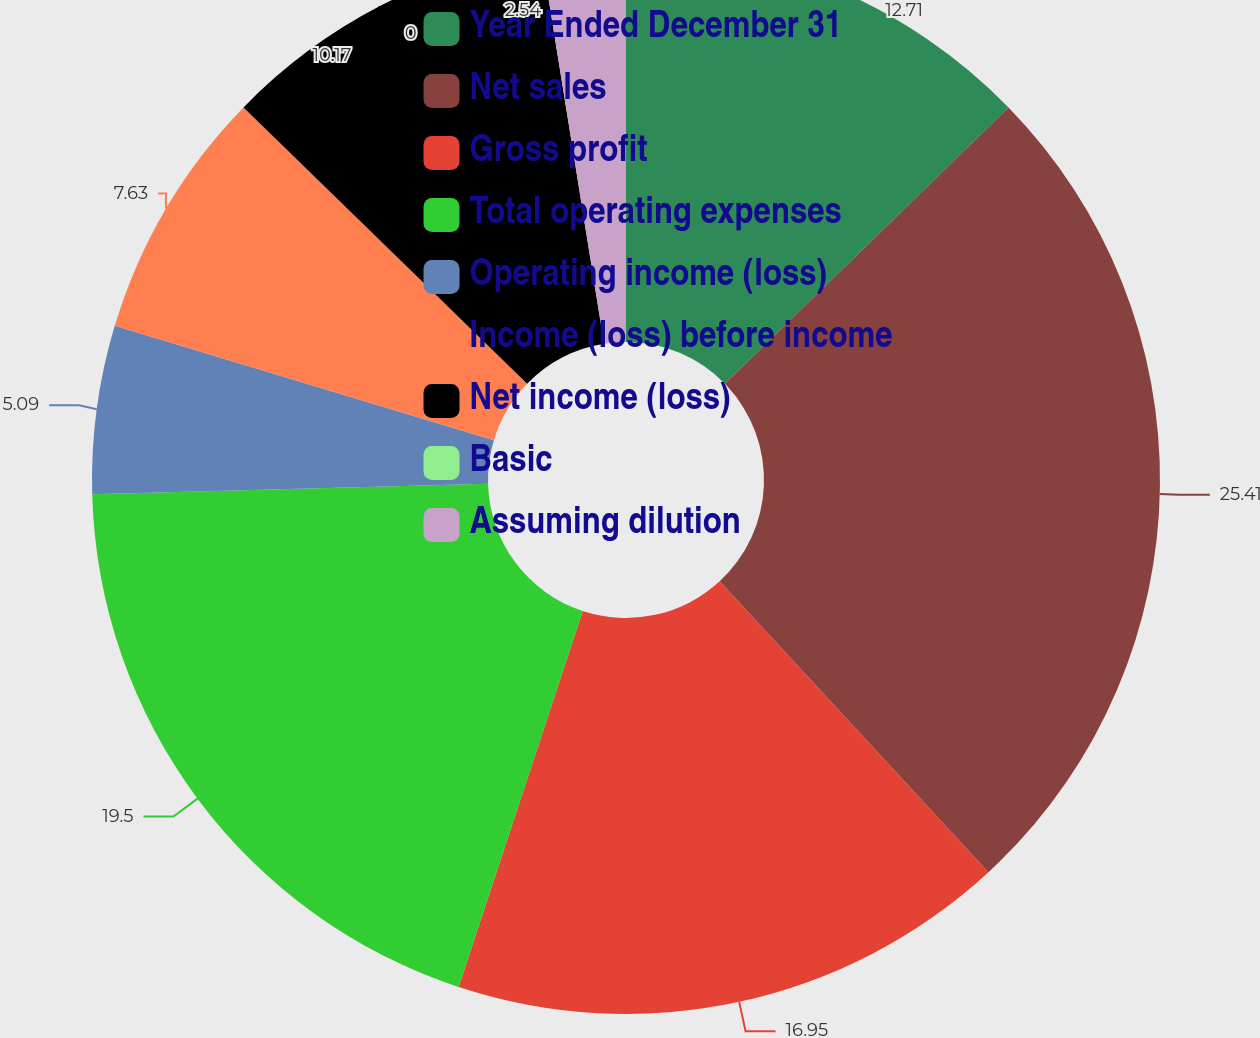Convert chart to OTSL. <chart><loc_0><loc_0><loc_500><loc_500><pie_chart><fcel>Year Ended December 31<fcel>Net sales<fcel>Gross profit<fcel>Total operating expenses<fcel>Operating income (loss)<fcel>Income (loss) before income<fcel>Net income (loss)<fcel>Basic<fcel>Assuming dilution<nl><fcel>12.71%<fcel>25.42%<fcel>16.95%<fcel>19.5%<fcel>5.09%<fcel>7.63%<fcel>10.17%<fcel>0.0%<fcel>2.54%<nl></chart> 